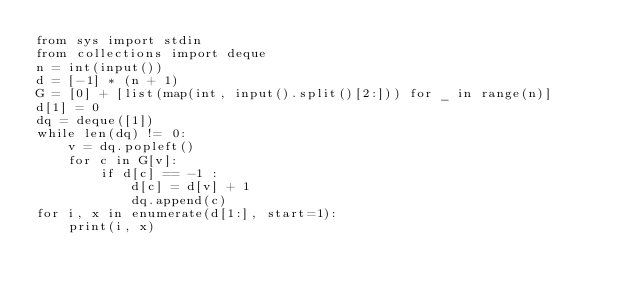<code> <loc_0><loc_0><loc_500><loc_500><_Python_>from sys import stdin
from collections import deque
n = int(input())
d = [-1] * (n + 1)
G = [0] + [list(map(int, input().split()[2:])) for _ in range(n)]
d[1] = 0
dq = deque([1])
while len(dq) != 0:
    v = dq.popleft()
    for c in G[v]:
        if d[c] == -1 :
            d[c] = d[v] + 1
            dq.append(c)
for i, x in enumerate(d[1:], start=1):
    print(i, x)</code> 